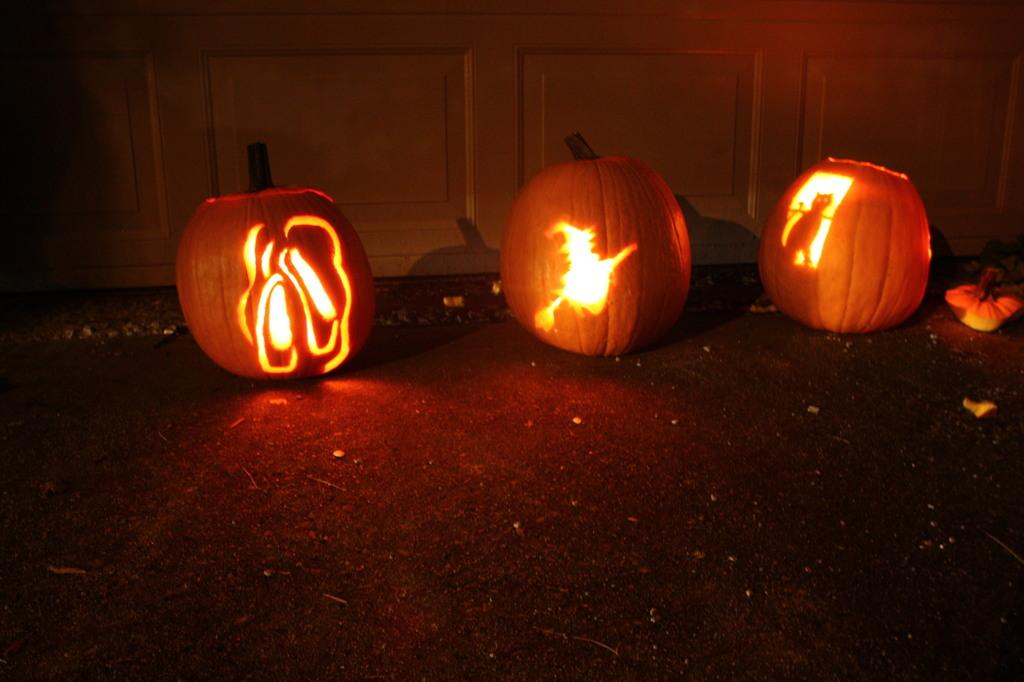What is the main focus of the image? There are Halloween decorations in the center of the image. Can you describe the background of the image? There is a white cupboard in the background of the image. Where is the surprise located in the image? There is no surprise mentioned or visible in the image. Can you see a playground in the image? No, there is no playground present in the image. 